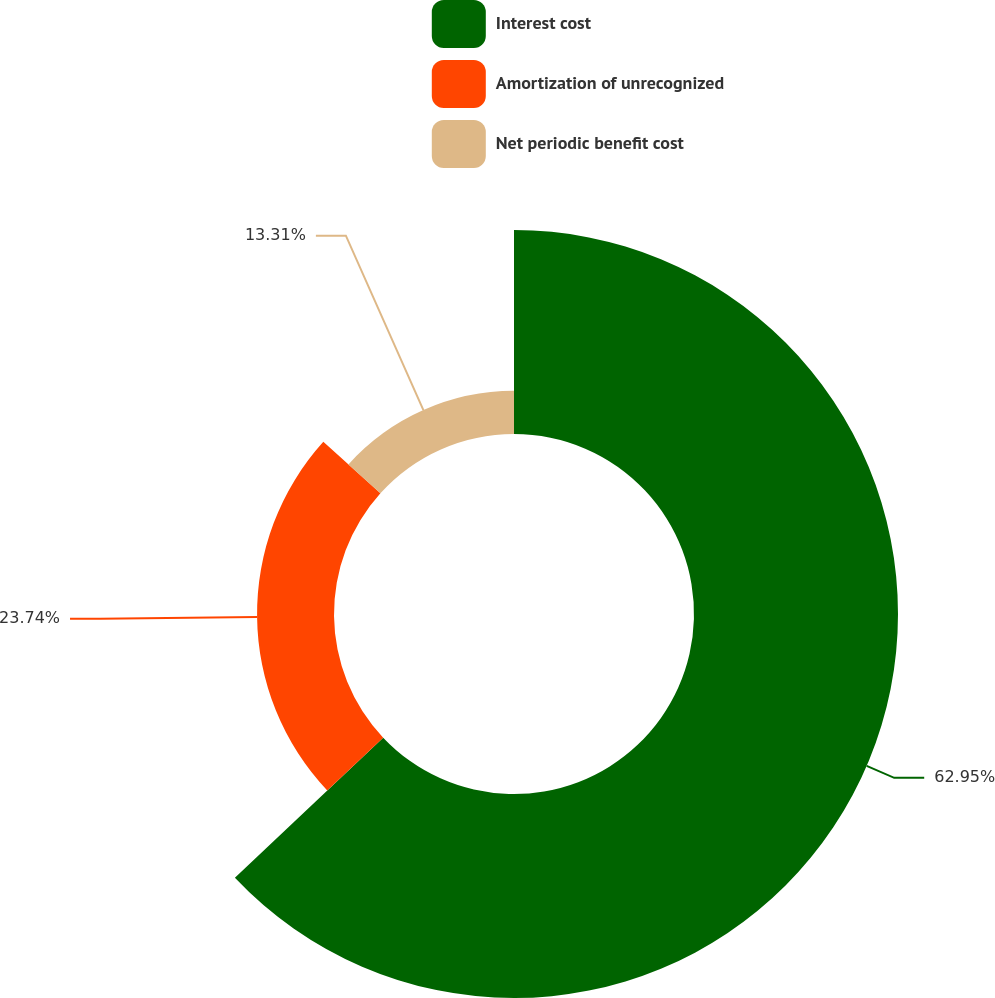Convert chart. <chart><loc_0><loc_0><loc_500><loc_500><pie_chart><fcel>Interest cost<fcel>Amortization of unrecognized<fcel>Net periodic benefit cost<nl><fcel>62.95%<fcel>23.74%<fcel>13.31%<nl></chart> 